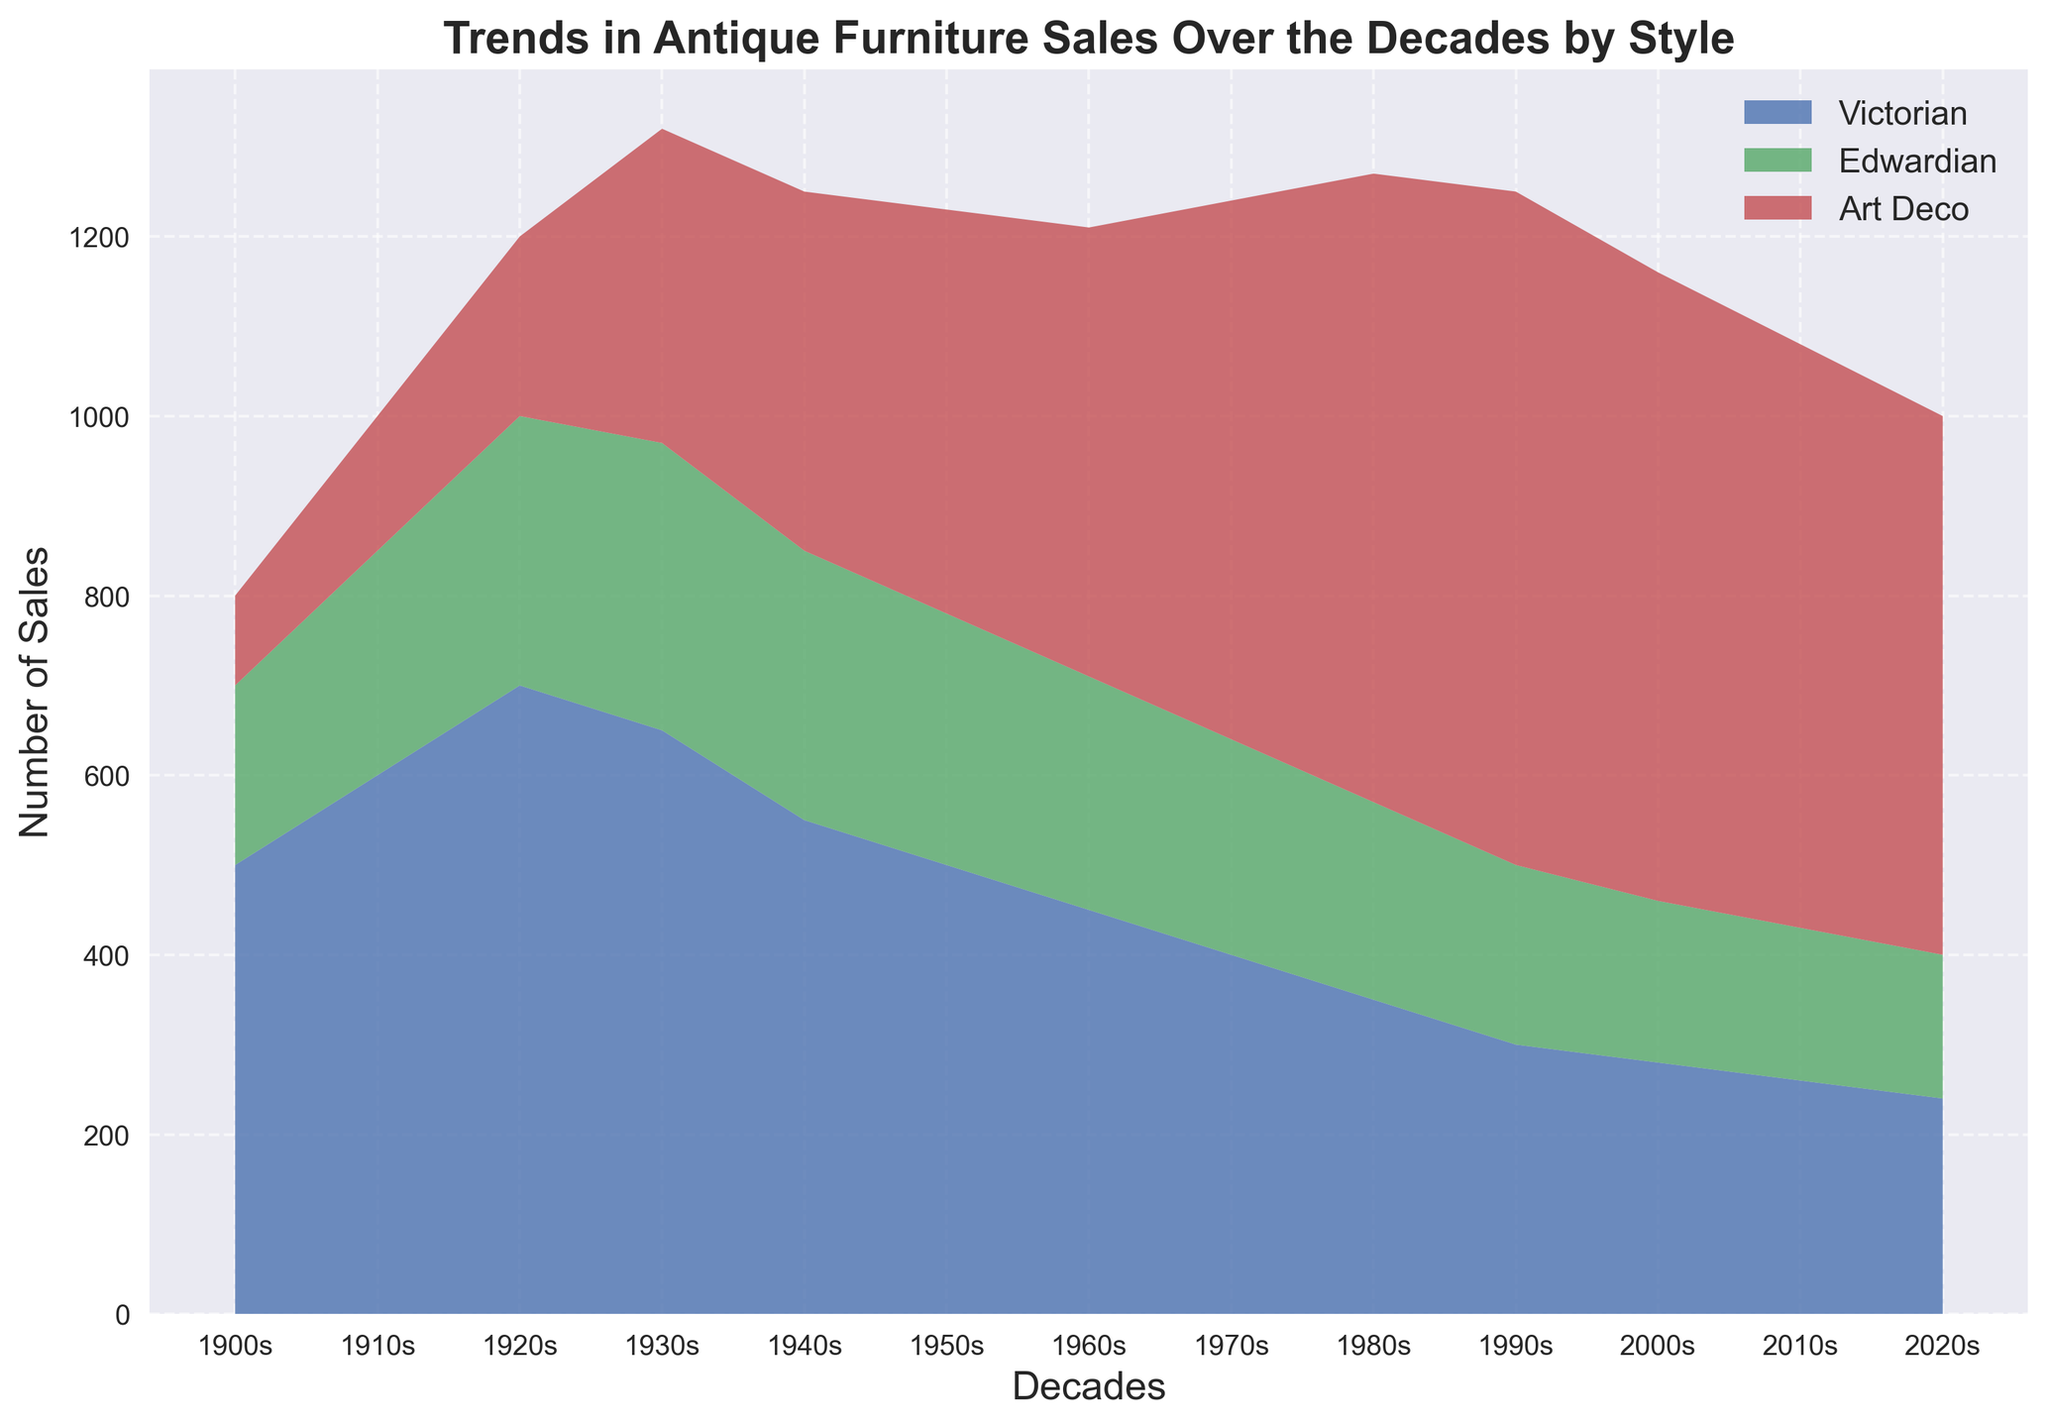What's the trend in the sales of Victorian furniture from the 1900s to 2020s? To discern the trend, observe the changing heights of the Victorian section in the area chart from 1900s to 2020s. The height indicates the number of sales. The Victorian sales start at 500 in the 1900s and decrease steadily to 240 in the 2020s.
Answer: Declining In which decade did Art Deco furniture sales surpass the other styles? Compare the heights of the sections in the area chart corresponding to Art Deco, Edwardian, and Victorian sales. In the 1930s, Art Deco surpasses Edwardian, then continues to increase, surpassing Victorian by the 1960s and is highest until the 2020s.
Answer: 1960s What is the sum of Edwardian and Art Deco furniture sales in the 1940s? Look for the sales numbers for Edwardian and Art Deco in the 1940s. The Edwardian sales are 300, and the Art Deco sales are 400. Adding these values gives 700.
Answer: 700 How do sales of Art Deco furniture in the 2000s compare to Victorian and Edwardian sales combined in the same decade? Look at the heights for each style in the 2000s. Art Deco sales are 700, Victorian sales are 280, and Edwardian sales are 180. Adding Victorian and Edwardian gives 460. Therefore, Art Deco (700) is higher than the combined sales of Victorian and Edwardian (460).
Answer: Art Deco is higher When did Edwardian furniture sales peak? Examine the height of the Edwardian section in the area chart. Edwardian sales peak in the 1930s at 320, and then start to decline.
Answer: 1930s What's the average number of sales for Victorian furniture from the 1900s to the 2020s? Add the number of Victorian sales for each decade: 500, 600, 700, 650, 550, 500, 450, 400, 350, 300, 280, 260, 240. Sum these values to get 5780. Divide by the number of decades (13) for the average: 5780 / 13 ≈ 444.6
Answer: 444.6 Which style had the most consistent number of sales across the decades? Review the area chart for fluctuating highs and lows in each style. Victorian sales decline gradually, Edwardian has fluctuations with a peak and then a decline, while Art Deco shows an increasing trend until the 1990s, then a mild decline. Victorian has the most consistent downward trend without large fluctuations.
Answer: Victorian How many more Edwardian furniture sales were there in the 1930s compared to the 1980s? Locate the Edwardian sales in the 1930s (320) and the 1980s (220). Subtract the 1980s value from the 1930s value: 320 - 220 = 100.
Answer: 100 Which style was dominant in the 1950s? Look at the highest section of the area chart for the 1950s. The Art Deco section is the tallest, indicating the highest number of sales.
Answer: Art Deco 